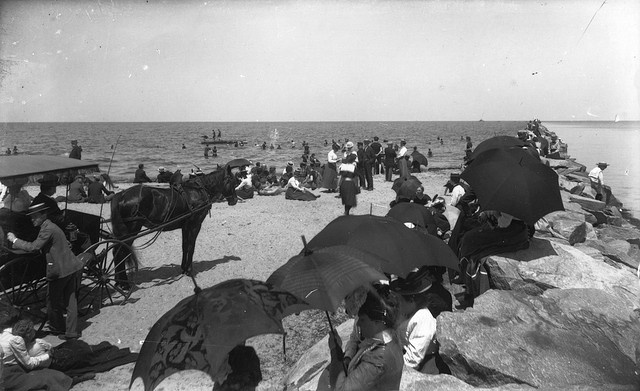Describe the objects in this image and their specific colors. I can see people in gray, black, darkgray, and lightgray tones, umbrella in black and gray tones, horse in gray, black, darkgray, and lightgray tones, umbrella in black, gray, and darkgray tones, and people in gray, black, darkgray, and lightgray tones in this image. 